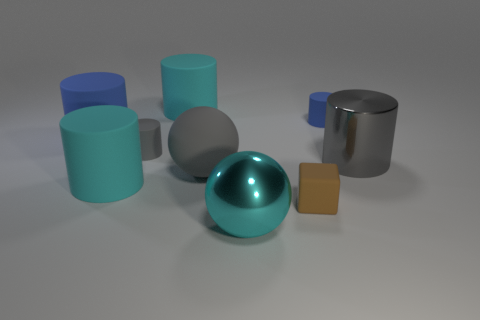Are there any big gray metallic things of the same shape as the small gray object?
Give a very brief answer. Yes. Is the gray metallic object the same shape as the tiny blue thing?
Give a very brief answer. Yes. How many large things are gray rubber objects or blocks?
Give a very brief answer. 1. Is the number of big metallic cylinders greater than the number of tiny rubber cylinders?
Your answer should be very brief. No. There is a gray cylinder that is the same material as the brown block; what is its size?
Offer a very short reply. Small. There is a blue cylinder on the right side of the cyan metal thing; does it have the same size as the blue cylinder on the left side of the big metal sphere?
Make the answer very short. No. What number of things are either rubber cylinders that are in front of the small blue thing or big metal things?
Offer a terse response. 5. Are there fewer big cyan metallic things than metallic cubes?
Provide a succinct answer. No. There is a cyan matte object behind the object that is on the right side of the matte cylinder on the right side of the brown rubber cube; what is its shape?
Offer a very short reply. Cylinder. There is a large metallic thing that is the same color as the matte ball; what is its shape?
Provide a succinct answer. Cylinder. 